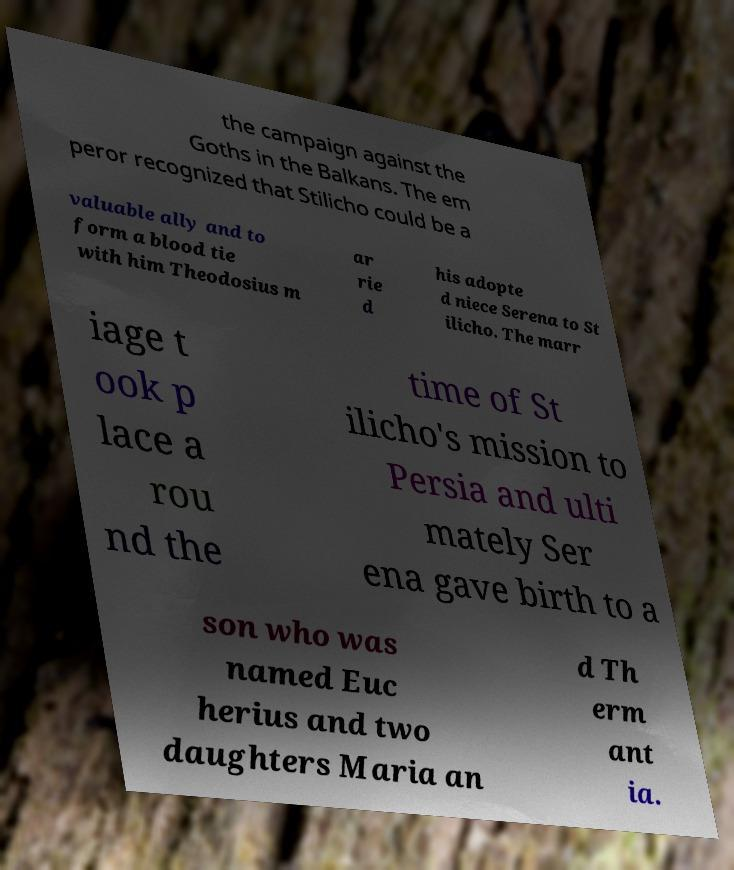For documentation purposes, I need the text within this image transcribed. Could you provide that? the campaign against the Goths in the Balkans. The em peror recognized that Stilicho could be a valuable ally and to form a blood tie with him Theodosius m ar rie d his adopte d niece Serena to St ilicho. The marr iage t ook p lace a rou nd the time of St ilicho's mission to Persia and ulti mately Ser ena gave birth to a son who was named Euc herius and two daughters Maria an d Th erm ant ia. 